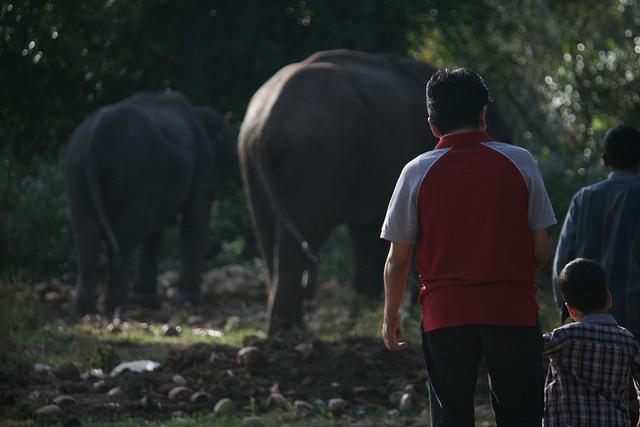How many elephants are in the picture?
Give a very brief answer. 2. How many people can you see?
Give a very brief answer. 3. 